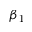<formula> <loc_0><loc_0><loc_500><loc_500>\beta _ { 1 }</formula> 